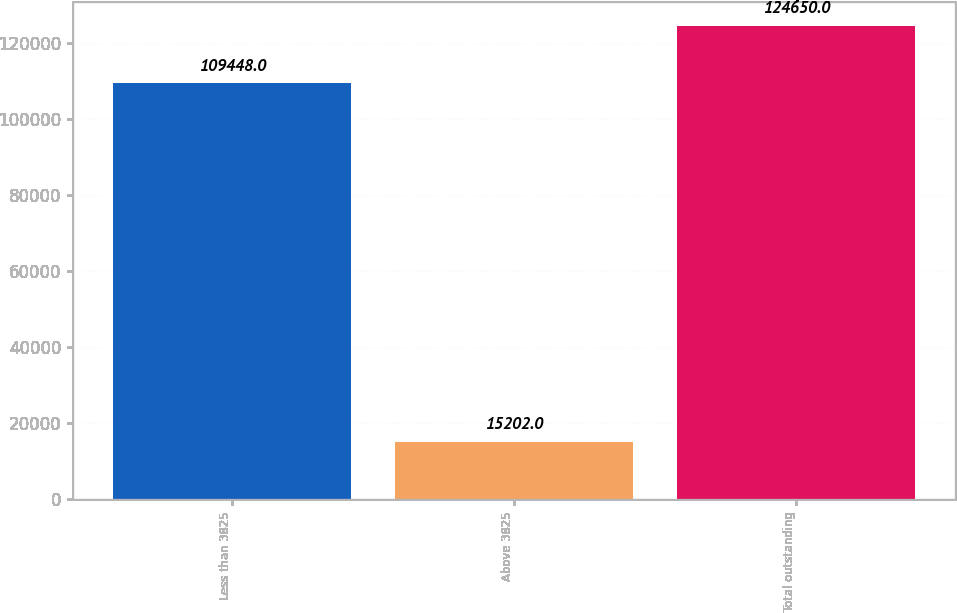Convert chart. <chart><loc_0><loc_0><loc_500><loc_500><bar_chart><fcel>Less than 3825<fcel>Above 3825<fcel>Total outstanding<nl><fcel>109448<fcel>15202<fcel>124650<nl></chart> 